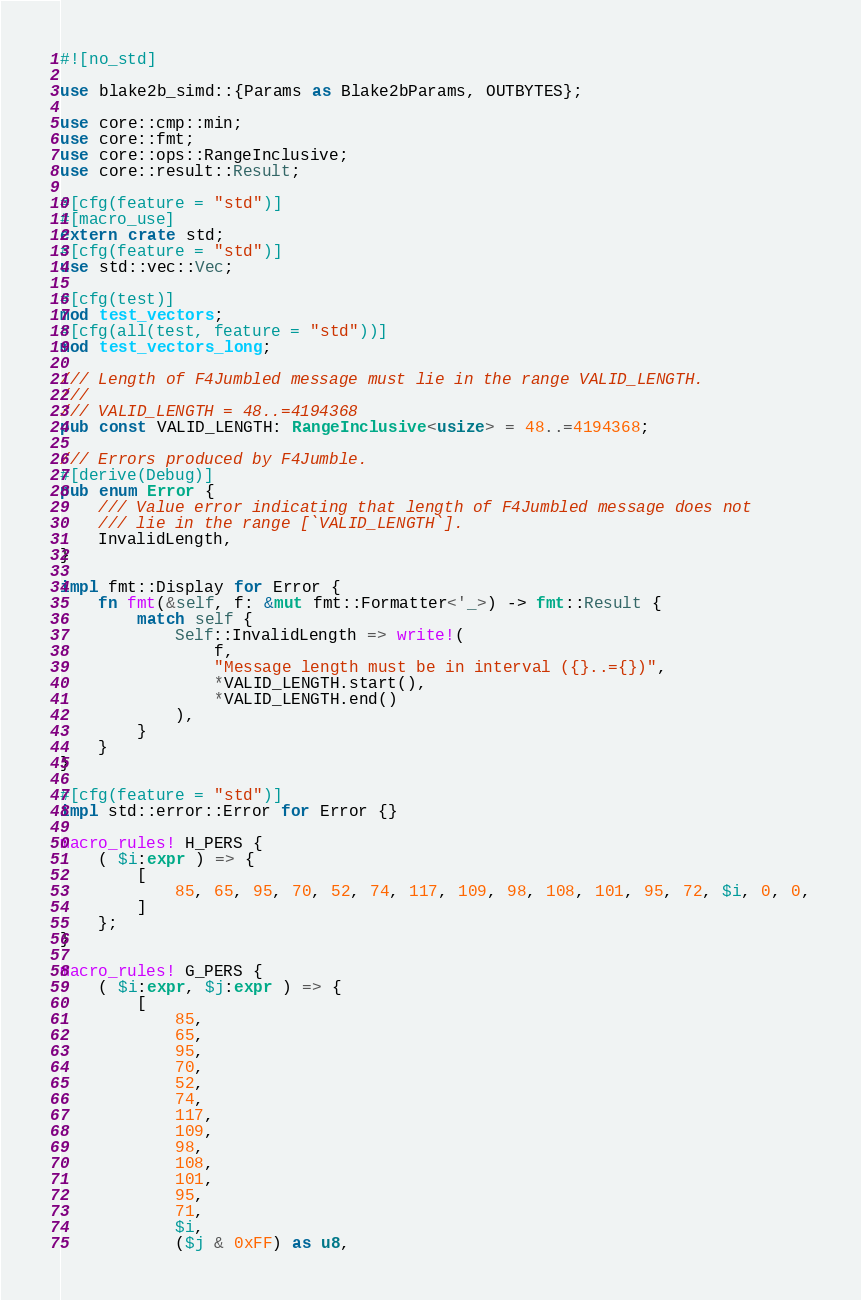<code> <loc_0><loc_0><loc_500><loc_500><_Rust_>#![no_std]

use blake2b_simd::{Params as Blake2bParams, OUTBYTES};

use core::cmp::min;
use core::fmt;
use core::ops::RangeInclusive;
use core::result::Result;

#[cfg(feature = "std")]
#[macro_use]
extern crate std;
#[cfg(feature = "std")]
use std::vec::Vec;

#[cfg(test)]
mod test_vectors;
#[cfg(all(test, feature = "std"))]
mod test_vectors_long;

/// Length of F4Jumbled message must lie in the range VALID_LENGTH.
///
/// VALID_LENGTH = 48..=4194368
pub const VALID_LENGTH: RangeInclusive<usize> = 48..=4194368;

/// Errors produced by F4Jumble.
#[derive(Debug)]
pub enum Error {
    /// Value error indicating that length of F4Jumbled message does not
    /// lie in the range [`VALID_LENGTH`].
    InvalidLength,
}

impl fmt::Display for Error {
    fn fmt(&self, f: &mut fmt::Formatter<'_>) -> fmt::Result {
        match self {
            Self::InvalidLength => write!(
                f,
                "Message length must be in interval ({}..={})",
                *VALID_LENGTH.start(),
                *VALID_LENGTH.end()
            ),
        }
    }
}

#[cfg(feature = "std")]
impl std::error::Error for Error {}

macro_rules! H_PERS {
    ( $i:expr ) => {
        [
            85, 65, 95, 70, 52, 74, 117, 109, 98, 108, 101, 95, 72, $i, 0, 0,
        ]
    };
}

macro_rules! G_PERS {
    ( $i:expr, $j:expr ) => {
        [
            85,
            65,
            95,
            70,
            52,
            74,
            117,
            109,
            98,
            108,
            101,
            95,
            71,
            $i,
            ($j & 0xFF) as u8,</code> 